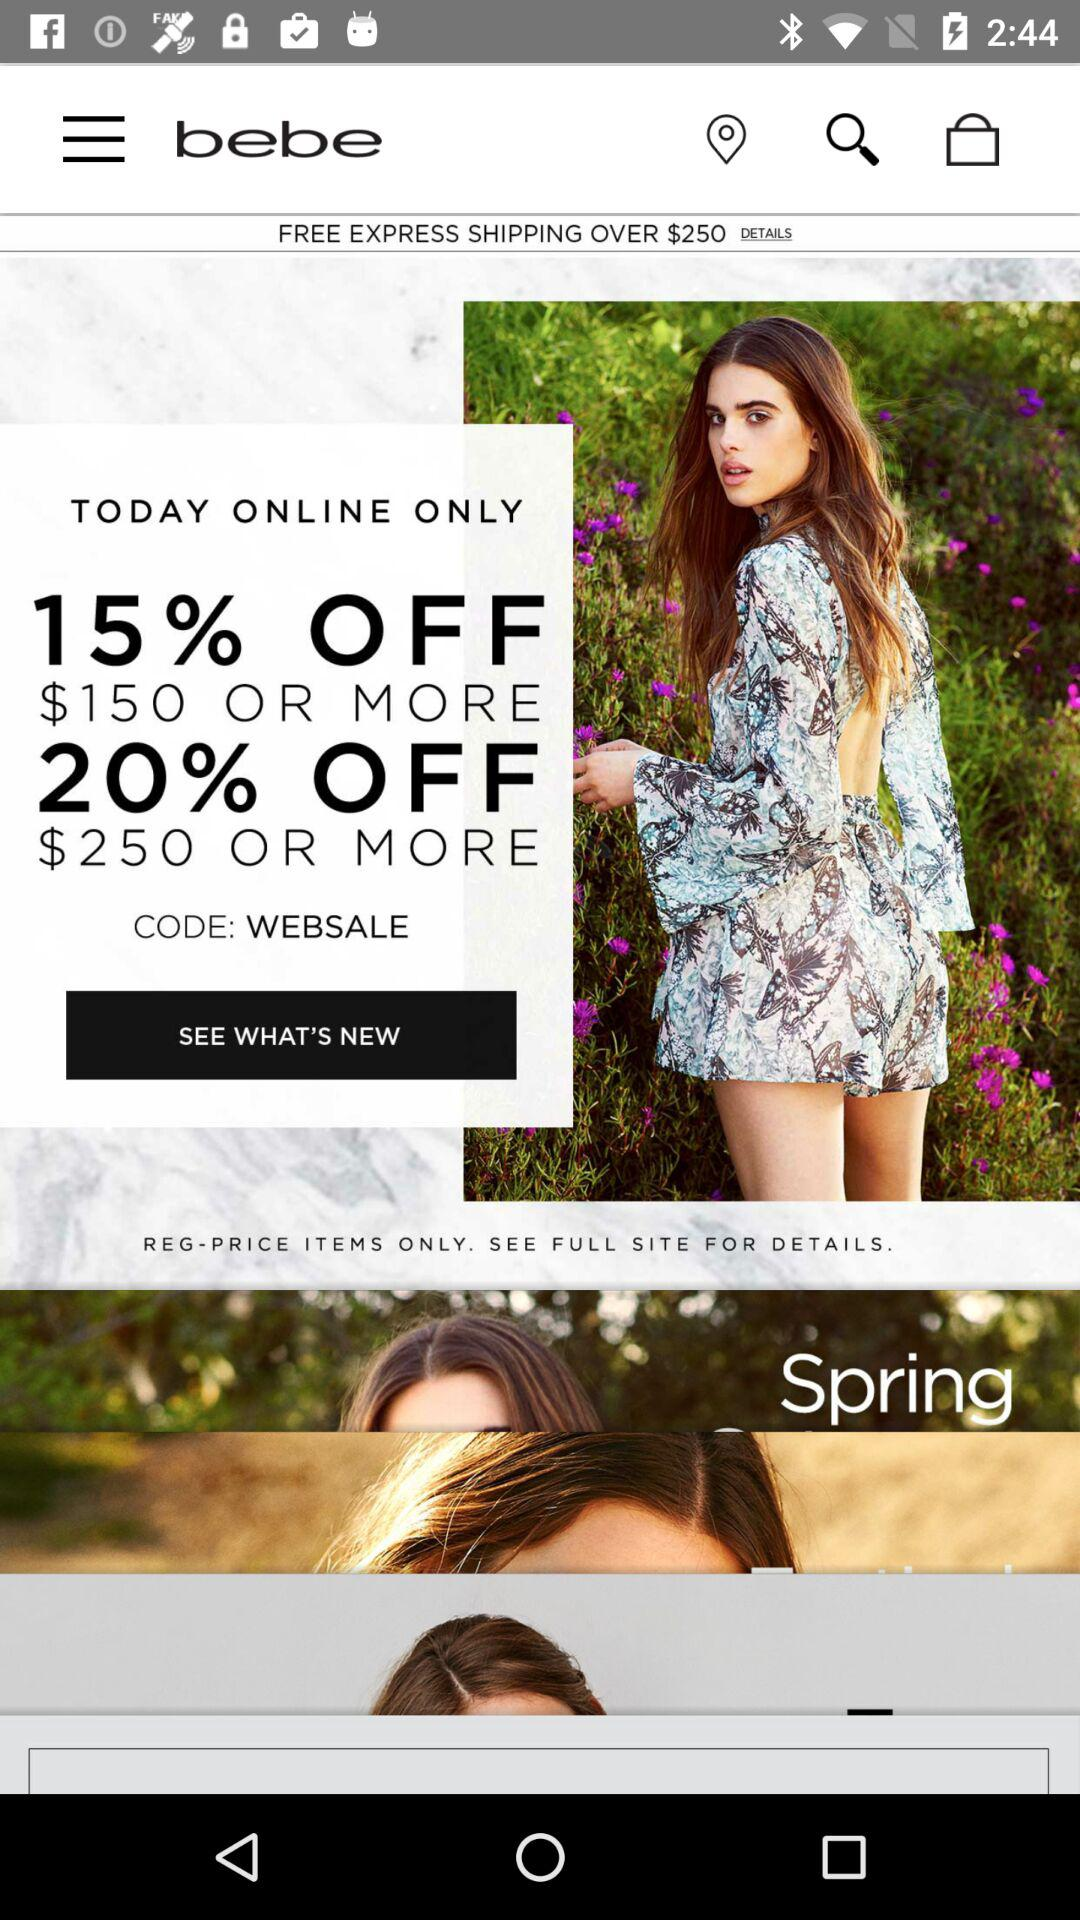At what amount is free shipping applicable? Free shipping is applicable for orders over $250. 